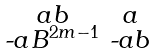Convert formula to latex. <formula><loc_0><loc_0><loc_500><loc_500>\begin{smallmatrix} a b & a \\ \text {-} a B ^ { 2 m - 1 } & \text {-} a b \end{smallmatrix}</formula> 